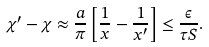Convert formula to latex. <formula><loc_0><loc_0><loc_500><loc_500>\chi ^ { \prime } - \chi \approx \frac { a } { \pi } \left [ \frac { 1 } { x } - \frac { 1 } { x ^ { \prime } } \right ] \leq \frac { \epsilon } { \tau S } .</formula> 